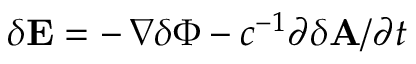Convert formula to latex. <formula><loc_0><loc_0><loc_500><loc_500>\delta { E } = - \, \nabla \delta \Phi - c ^ { - 1 } \partial \delta { A } / \partial t</formula> 